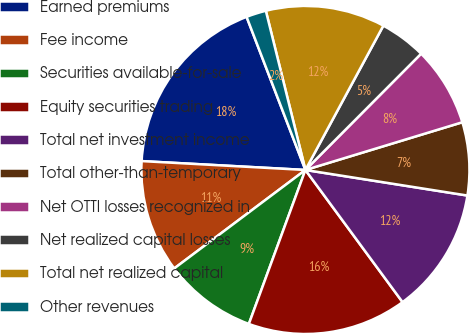<chart> <loc_0><loc_0><loc_500><loc_500><pie_chart><fcel>Earned premiums<fcel>Fee income<fcel>Securities available-for-sale<fcel>Equity securities trading<fcel>Total net investment income<fcel>Total other-than-temporary<fcel>Net OTTI losses recognized in<fcel>Net realized capital losses<fcel>Total net realized capital<fcel>Other revenues<nl><fcel>18.3%<fcel>11.11%<fcel>9.15%<fcel>15.69%<fcel>12.42%<fcel>7.19%<fcel>7.84%<fcel>4.58%<fcel>11.76%<fcel>1.96%<nl></chart> 